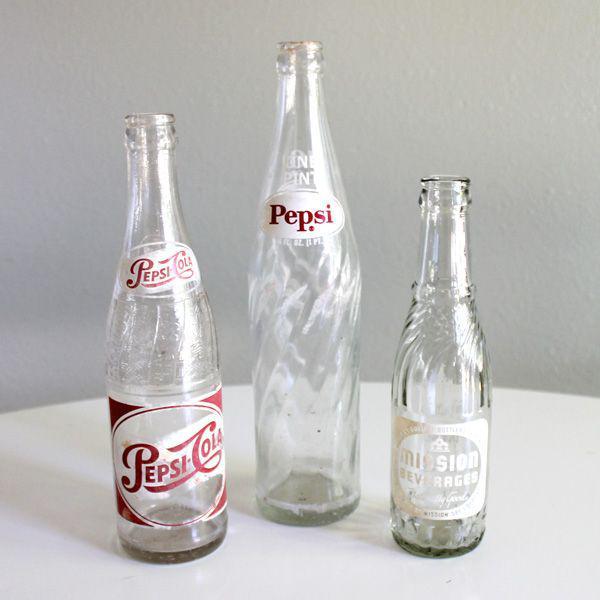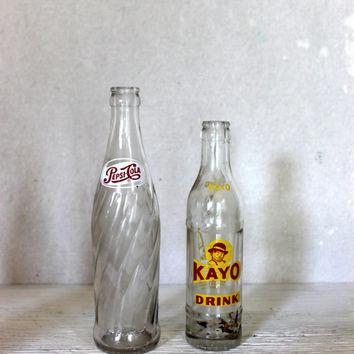The first image is the image on the left, the second image is the image on the right. Assess this claim about the two images: "There are fewer than six bottles in total.". Correct or not? Answer yes or no. Yes. The first image is the image on the left, the second image is the image on the right. For the images shown, is this caption "Each image contains three empty glass soda bottles, and at least one image features bottles with orange labels facing forward." true? Answer yes or no. No. 